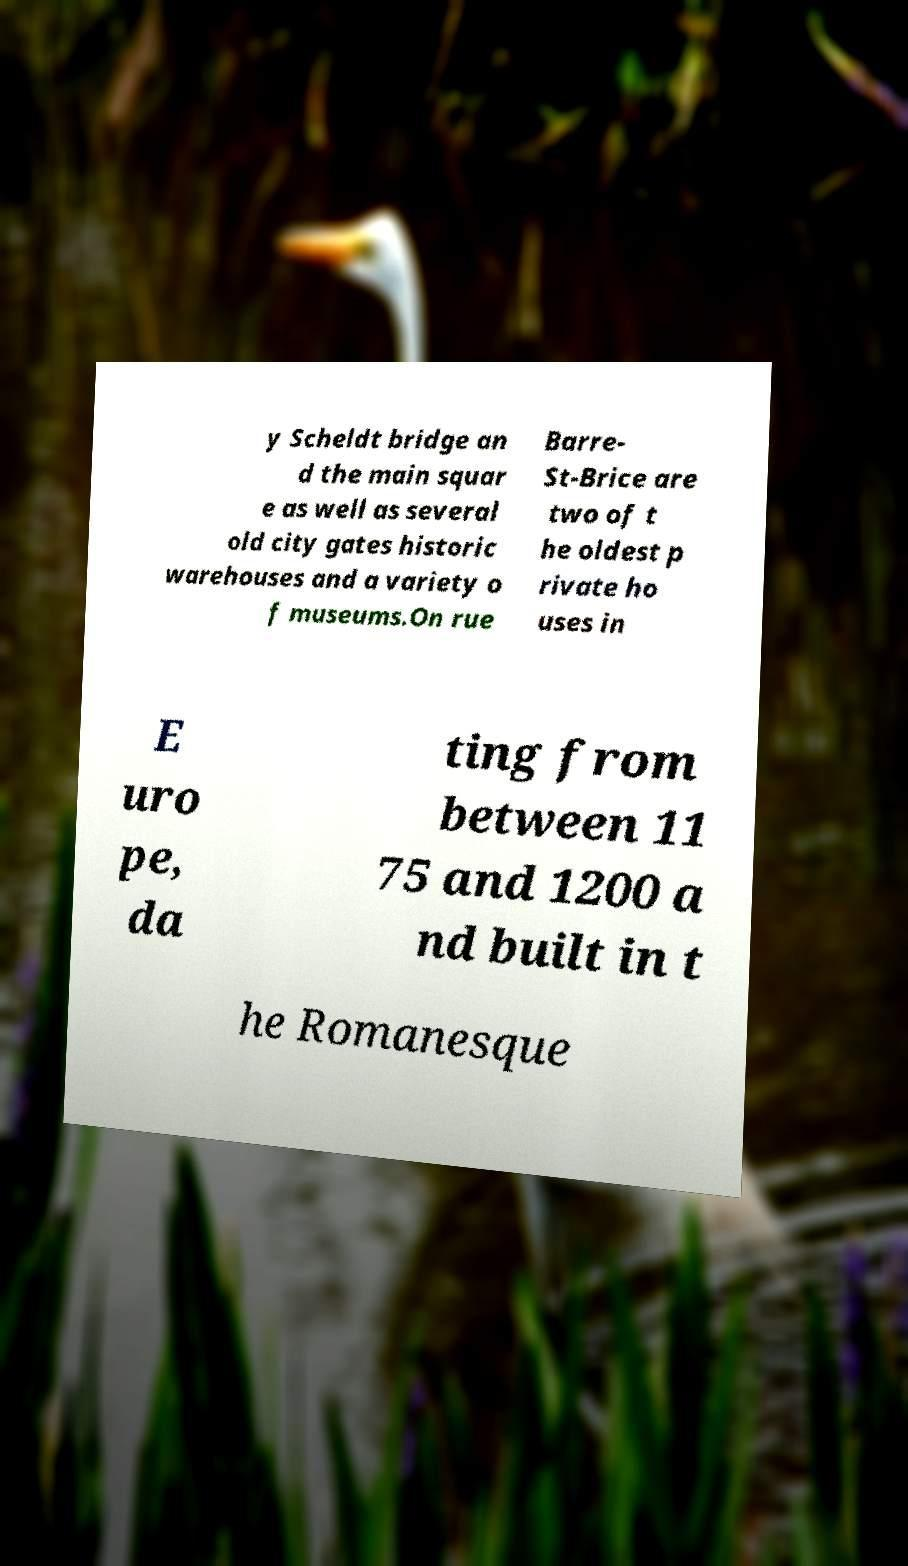I need the written content from this picture converted into text. Can you do that? y Scheldt bridge an d the main squar e as well as several old city gates historic warehouses and a variety o f museums.On rue Barre- St-Brice are two of t he oldest p rivate ho uses in E uro pe, da ting from between 11 75 and 1200 a nd built in t he Romanesque 